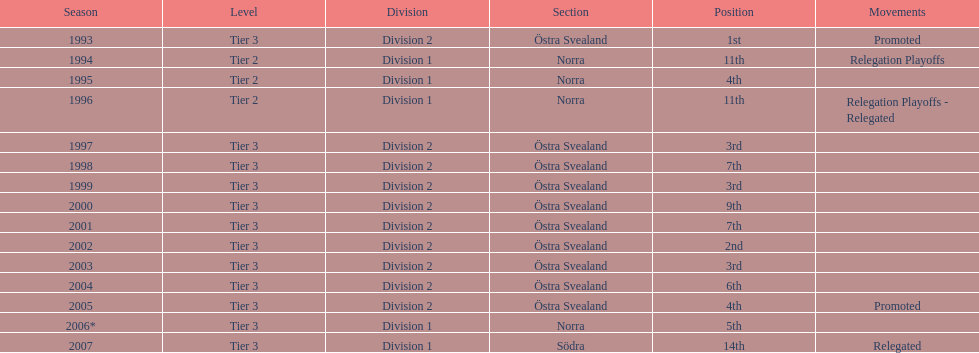What is the count of division 2 being listed as the division? 10. 